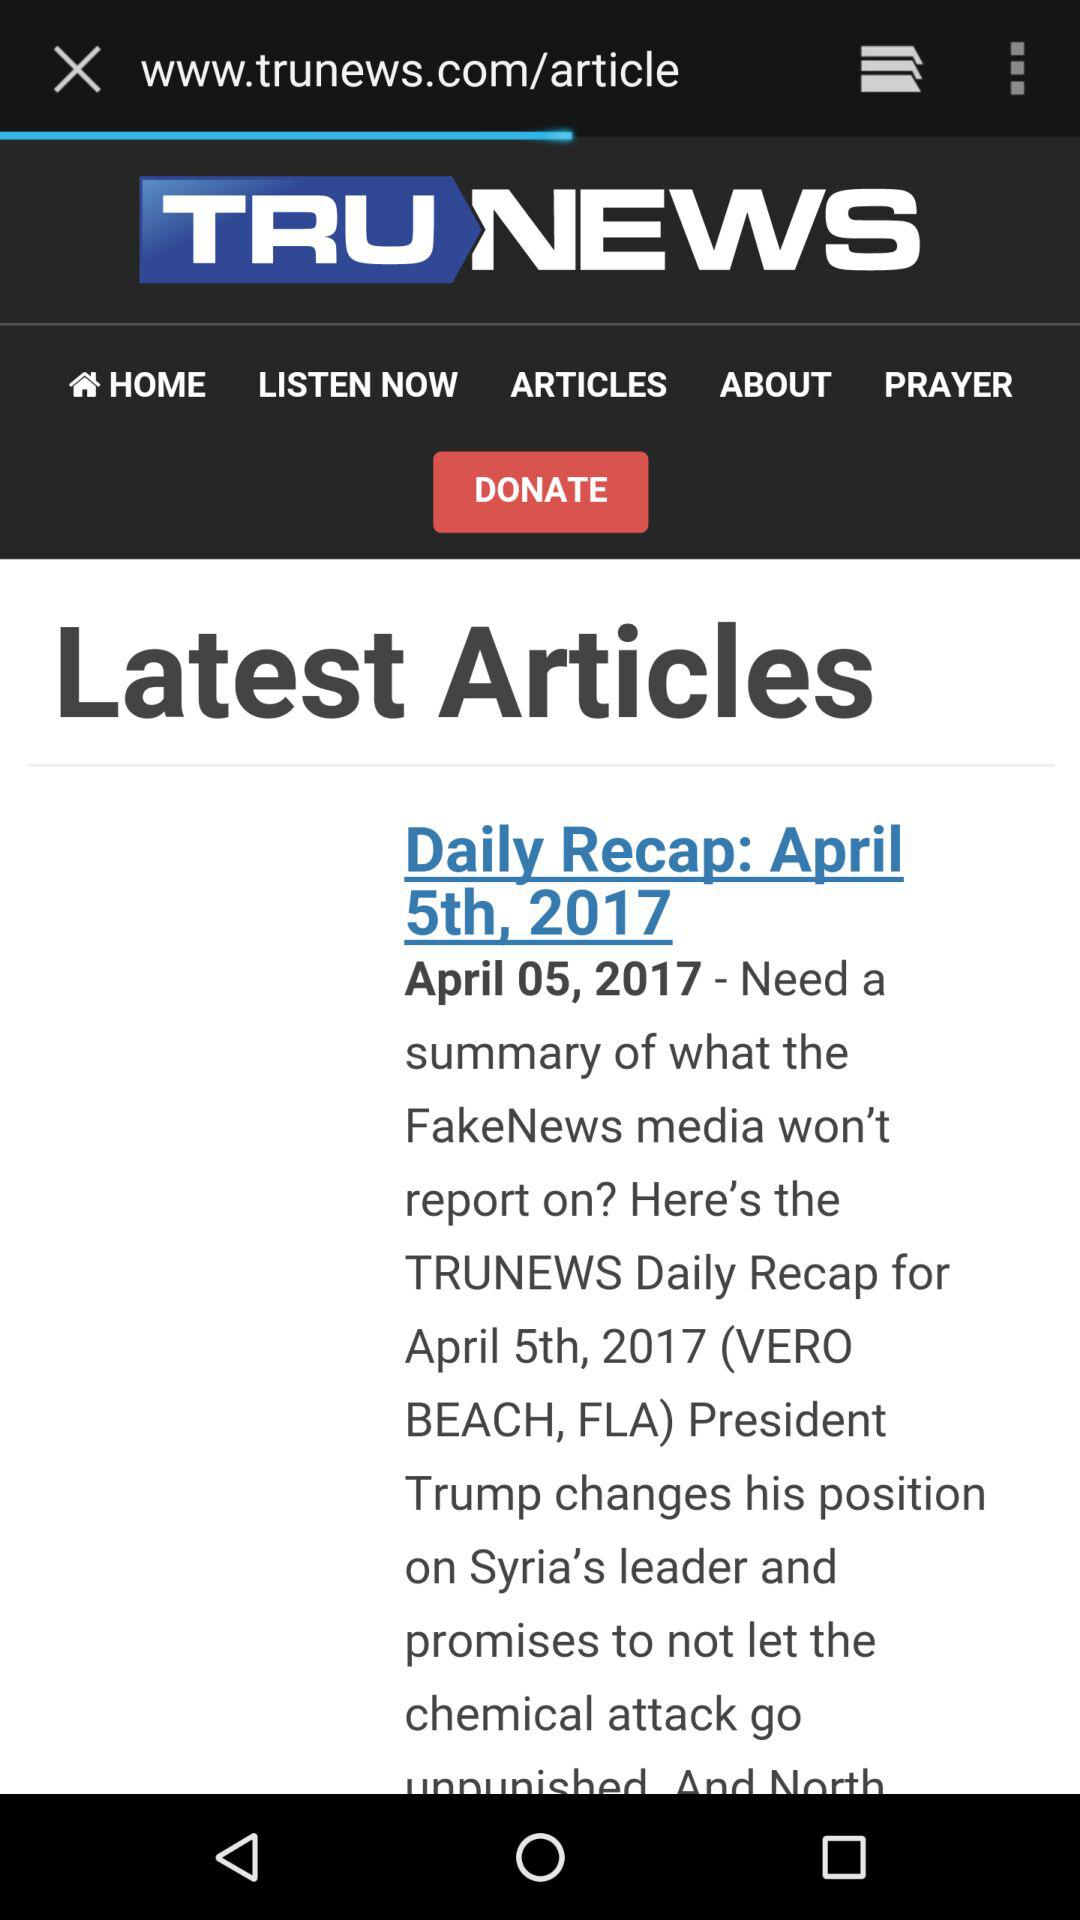On what date was the "TRUNEWS Daily Recap" news posted? The "TRUNEWS Daily Recap" news was posted on April 5th, 2017. 